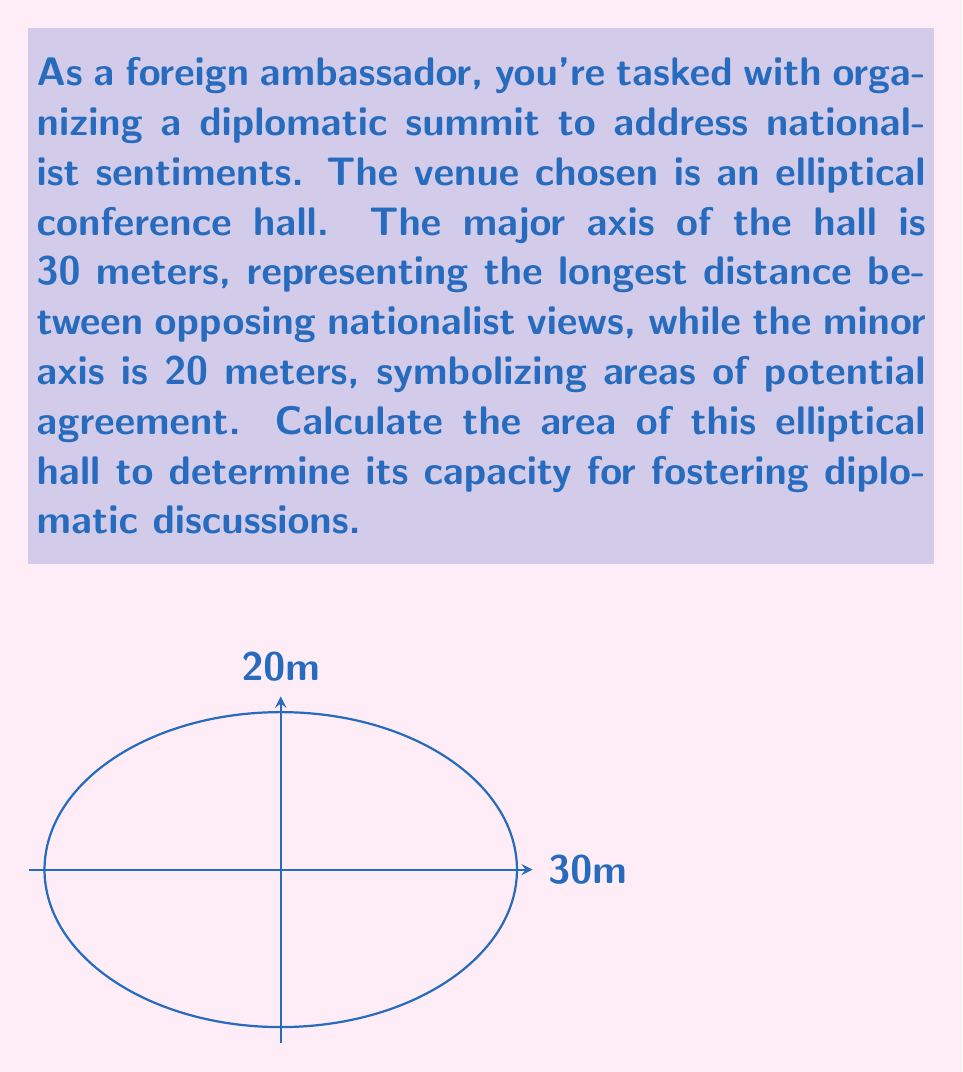Provide a solution to this math problem. To calculate the area of an ellipse, we use the formula:

$$A = \pi ab$$

Where:
$A$ is the area of the ellipse
$a$ is half the length of the major axis
$b$ is half the length of the minor axis

Given:
- Major axis = 30 meters
- Minor axis = 20 meters

Step 1: Calculate $a$ and $b$
$a = 30 \div 2 = 15$ meters
$b = 20 \div 2 = 10$ meters

Step 2: Apply the formula
$$A = \pi ab$$
$$A = \pi (15)(10)$$
$$A = 150\pi$$

Step 3: Calculate the final value (rounded to two decimal places)
$$A = 150 \times 3.14159...$$
$$A \approx 471.24 \text{ square meters}$$

This area represents the space available for diplomatic discussions, balancing the range of nationalist perspectives with opportunities for finding common ground.
Answer: $471.24 \text{ m}^2$ 